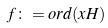<formula> <loc_0><loc_0><loc_500><loc_500>f \colon = o r d ( x H )</formula> 